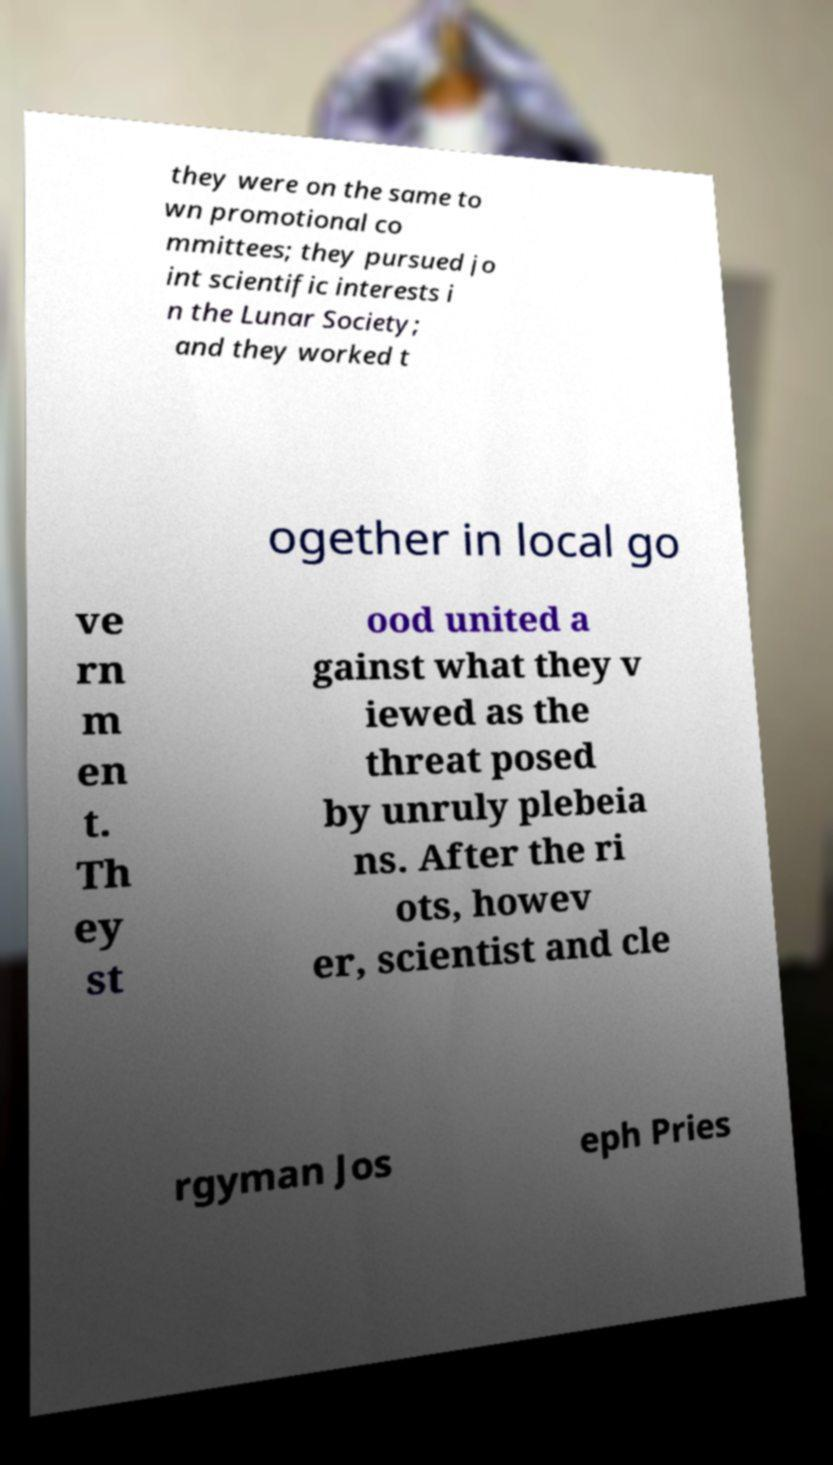Can you read and provide the text displayed in the image?This photo seems to have some interesting text. Can you extract and type it out for me? they were on the same to wn promotional co mmittees; they pursued jo int scientific interests i n the Lunar Society; and they worked t ogether in local go ve rn m en t. Th ey st ood united a gainst what they v iewed as the threat posed by unruly plebeia ns. After the ri ots, howev er, scientist and cle rgyman Jos eph Pries 